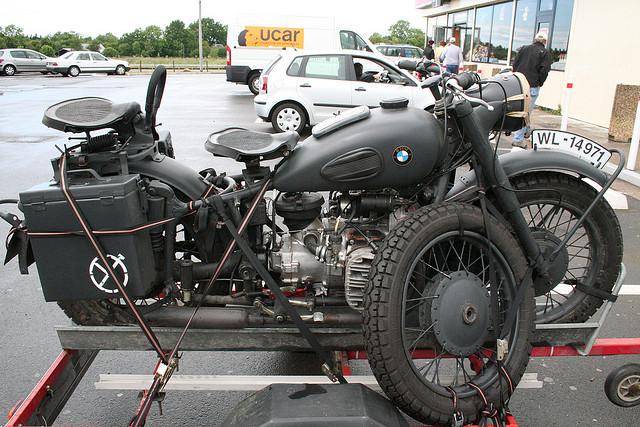Does this motorcycle need repaired?
Keep it brief. Yes. What is attached to the black motorcycle?
Be succinct. Tire. Is this a BMW motorbike?
Short answer required. Yes. Is this motorcycle on a trailer?
Write a very short answer. Yes. Can the bike fit on the trailer?
Write a very short answer. Yes. 